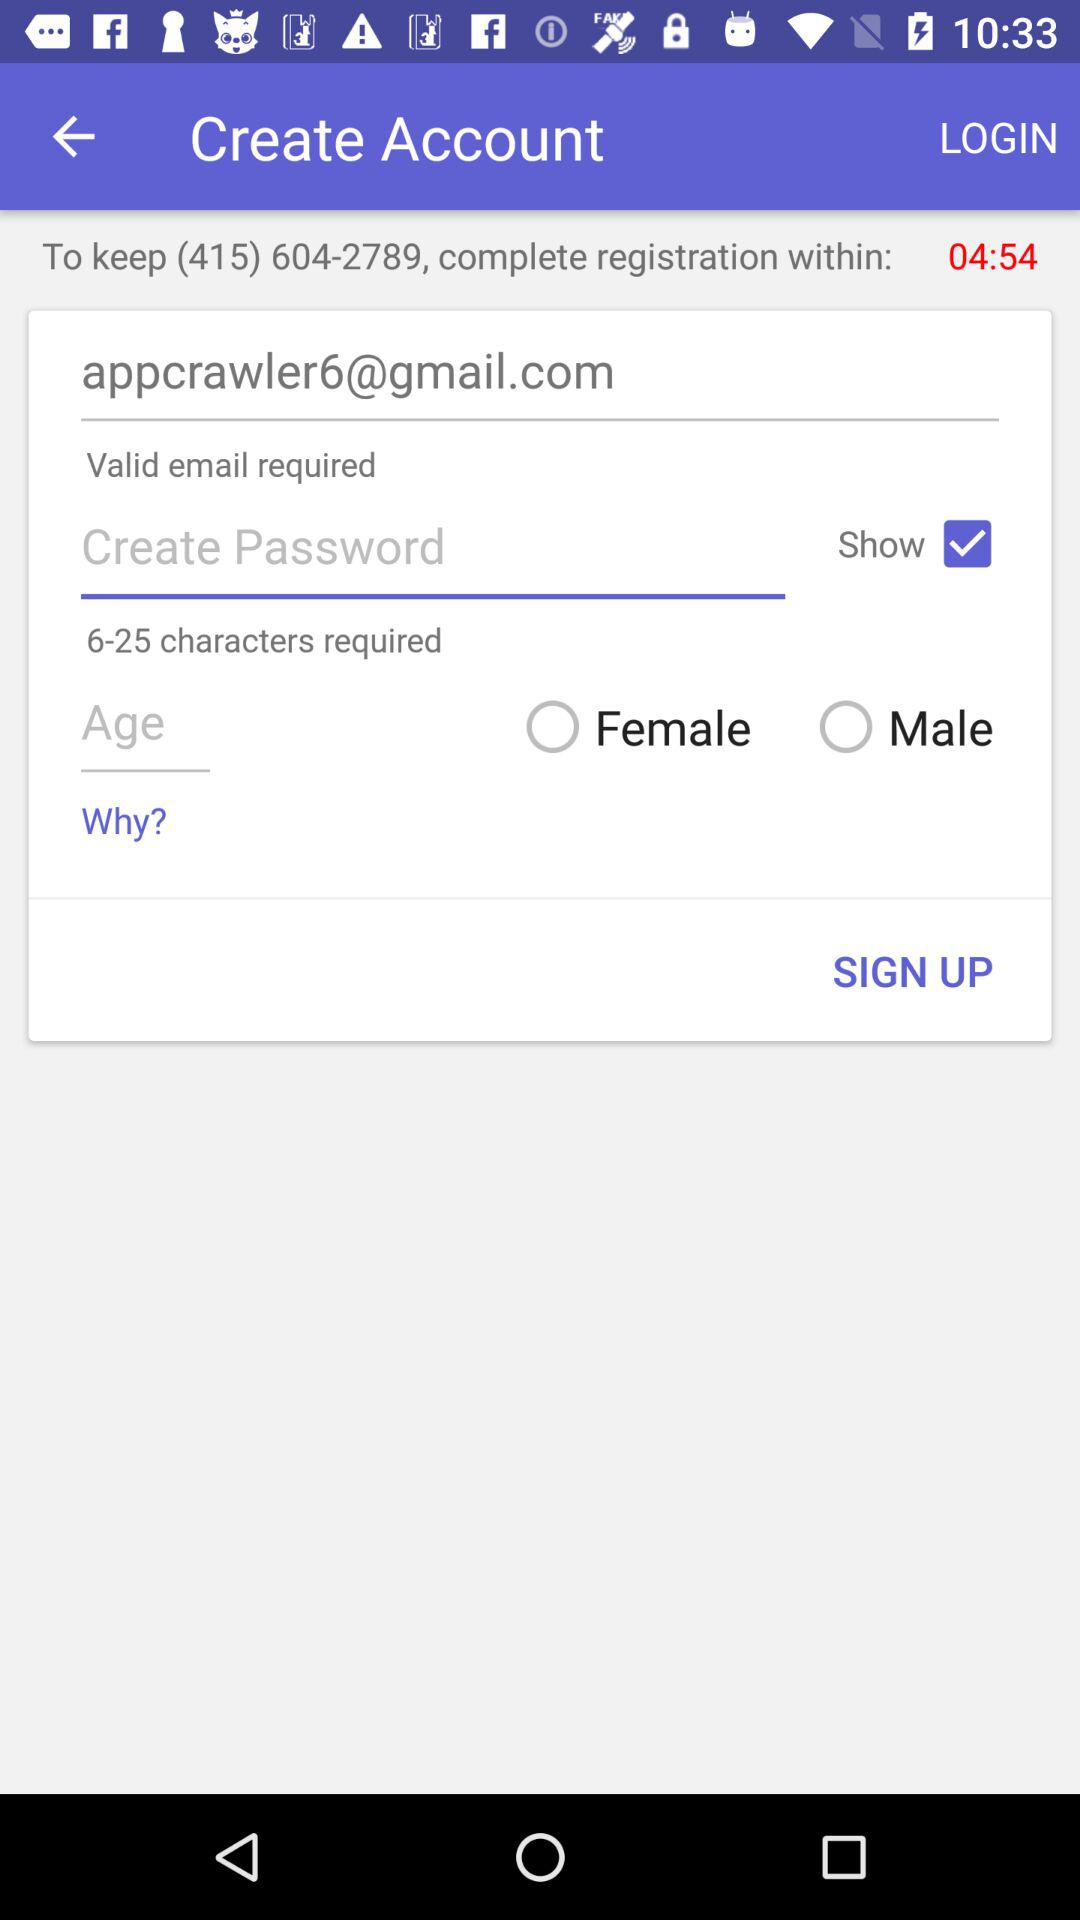How many characters are required to create a password? The characters required to create a password range from 6 to 25. 